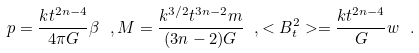<formula> <loc_0><loc_0><loc_500><loc_500>p = \frac { k t ^ { 2 n - 4 } } { 4 \pi G } \beta \ , M = \frac { k ^ { 3 / 2 } t ^ { 3 n - 2 } m } { ( 3 n - 2 ) G } \ , < B _ { t } ^ { 2 } > = \frac { k t ^ { 2 n - 4 } } { G } w \ .</formula> 